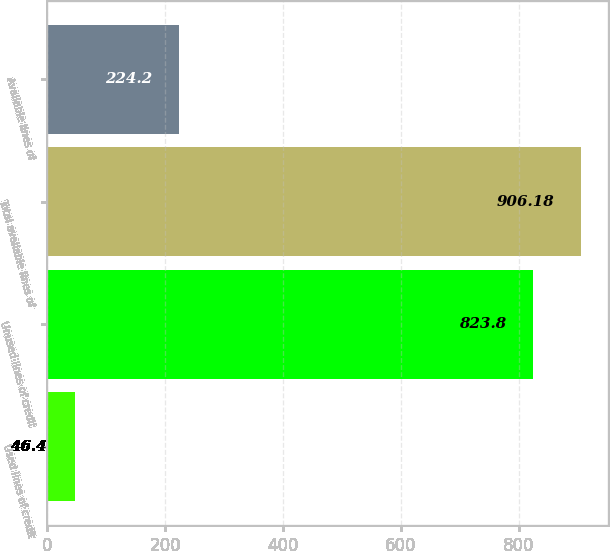Convert chart to OTSL. <chart><loc_0><loc_0><loc_500><loc_500><bar_chart><fcel>Used lines of credit<fcel>Unused lines of credit<fcel>Total available lines of<fcel>Available lines of<nl><fcel>46.4<fcel>823.8<fcel>906.18<fcel>224.2<nl></chart> 